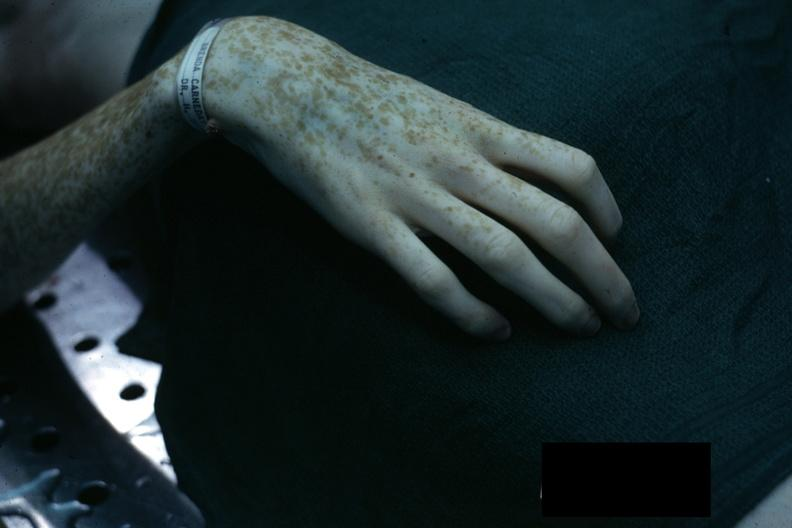what is present?
Answer the question using a single word or phrase. Hand 